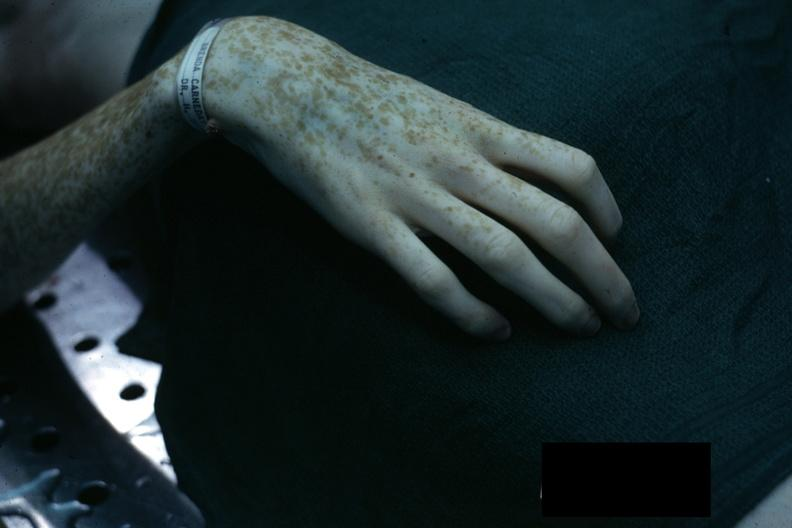what is present?
Answer the question using a single word or phrase. Hand 